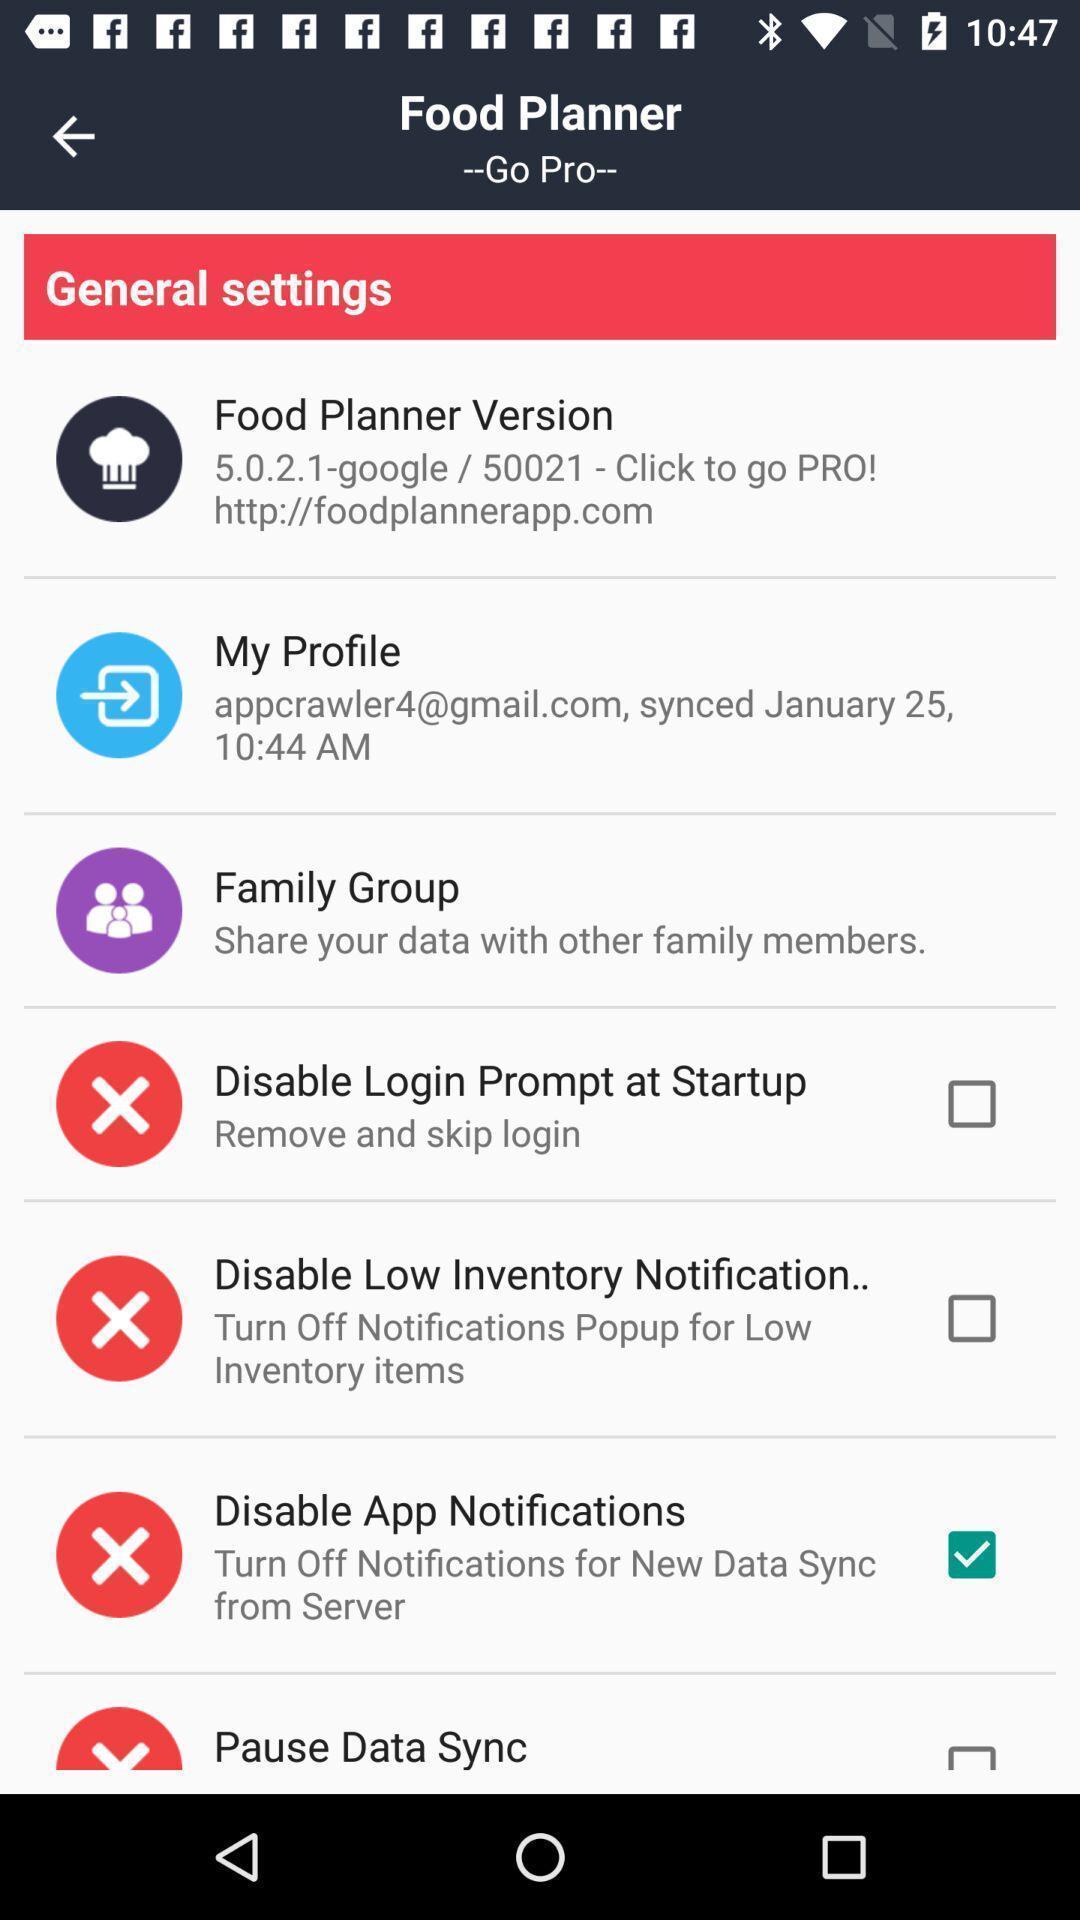Please provide a description for this image. Setting page displaying the various options. 